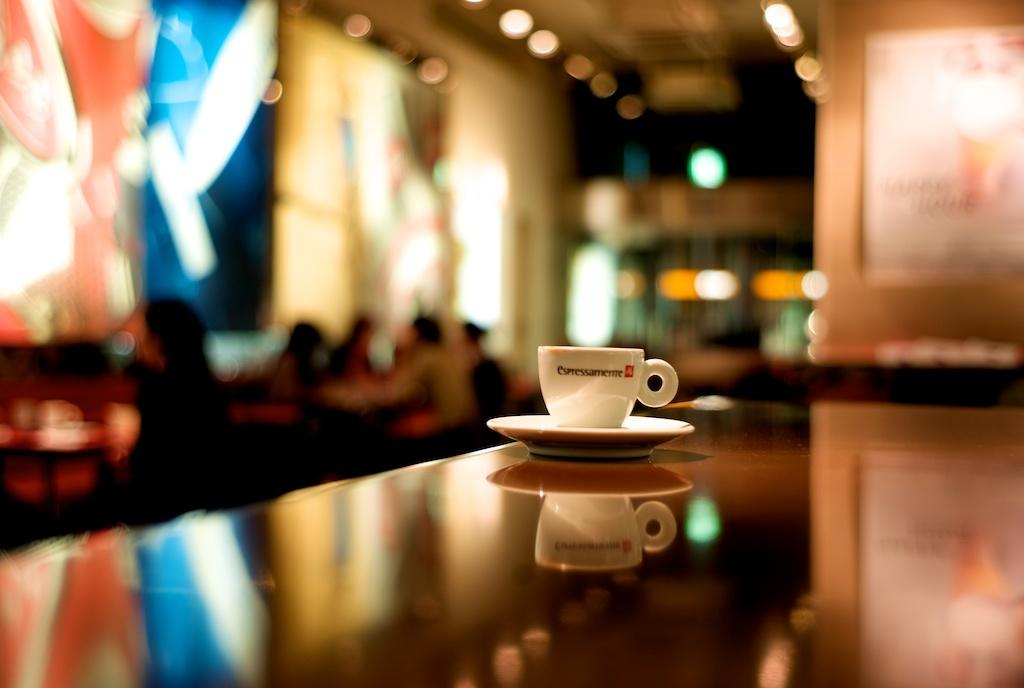What is on the table in the image? There is a coffee cup and a saucer on the table in the image. What is the coffee cup resting on? The coffee cup is resting on a saucer. Where are the people in the image sitting? The people in the image are sitting on chairs. What type of stitch is being used to sew the corn in the image? There is no corn or stitching present in the image. 